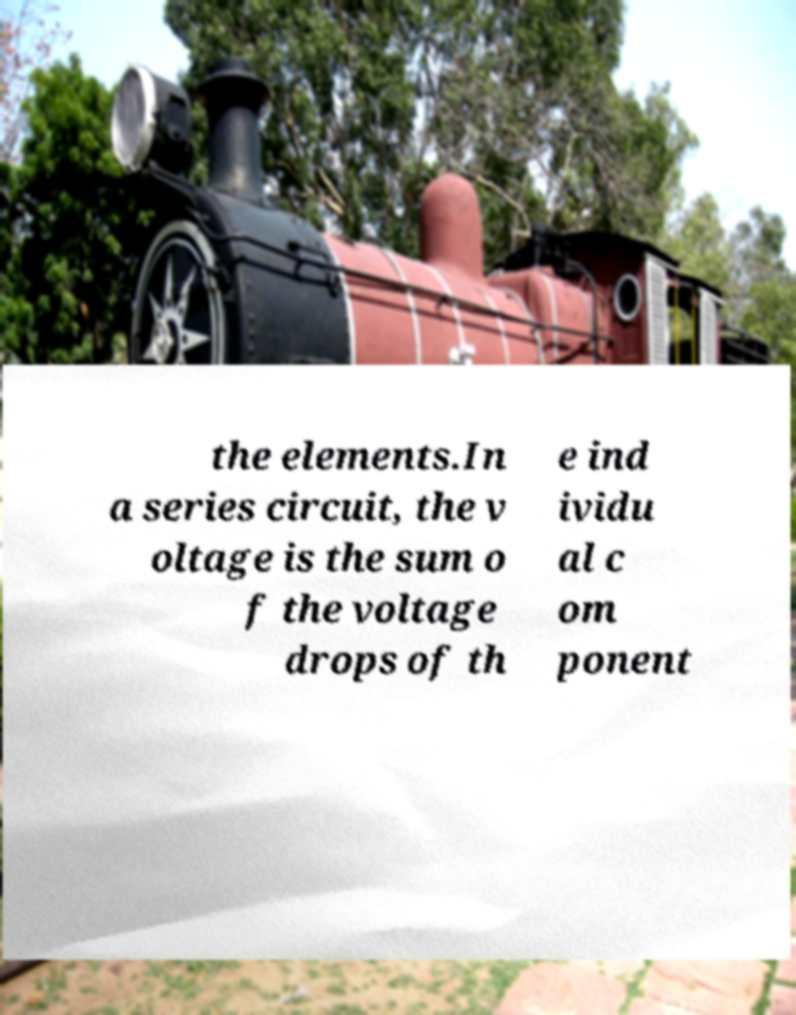Can you read and provide the text displayed in the image?This photo seems to have some interesting text. Can you extract and type it out for me? the elements.In a series circuit, the v oltage is the sum o f the voltage drops of th e ind ividu al c om ponent 